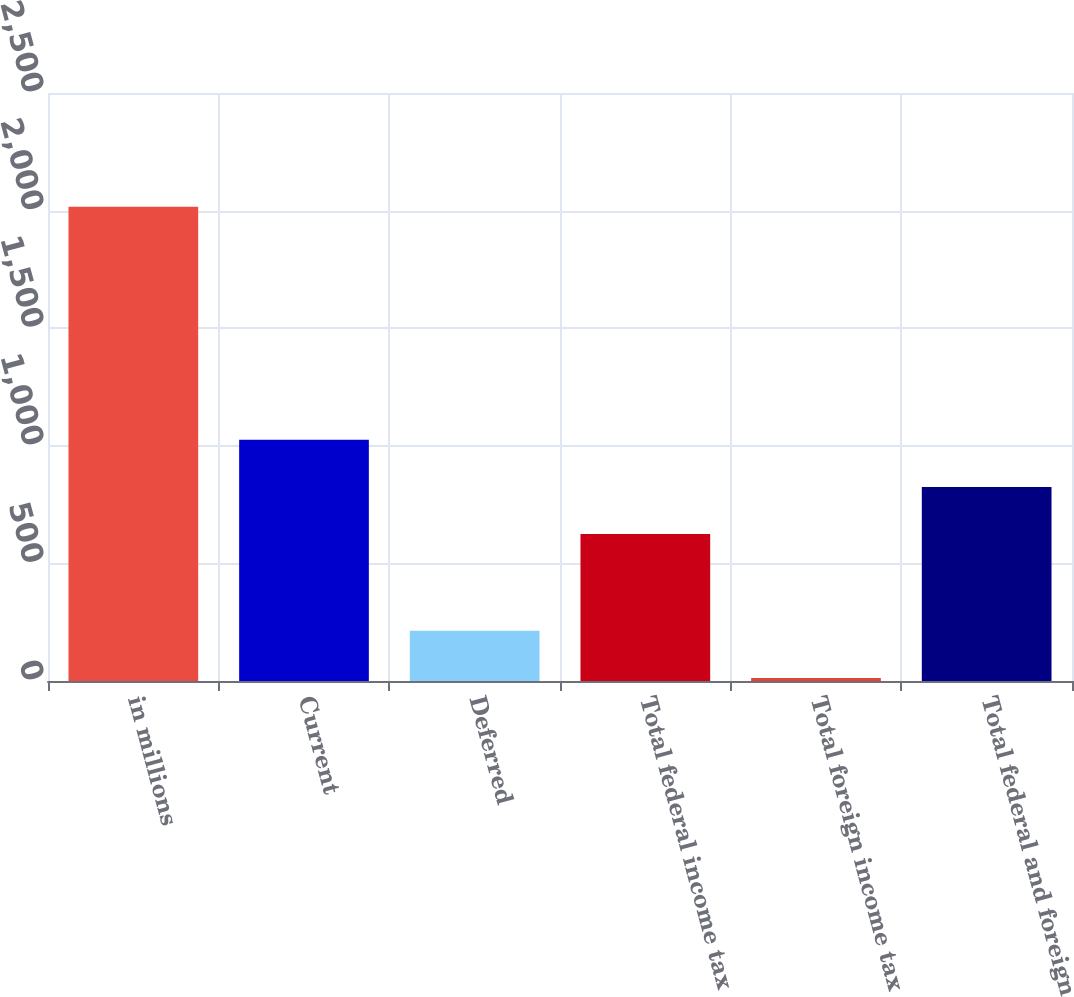Convert chart. <chart><loc_0><loc_0><loc_500><loc_500><bar_chart><fcel>in millions<fcel>Current<fcel>Deferred<fcel>Total federal income tax<fcel>Total foreign income tax<fcel>Total federal and foreign<nl><fcel>2016<fcel>1025.6<fcel>213.3<fcel>625<fcel>13<fcel>825.3<nl></chart> 